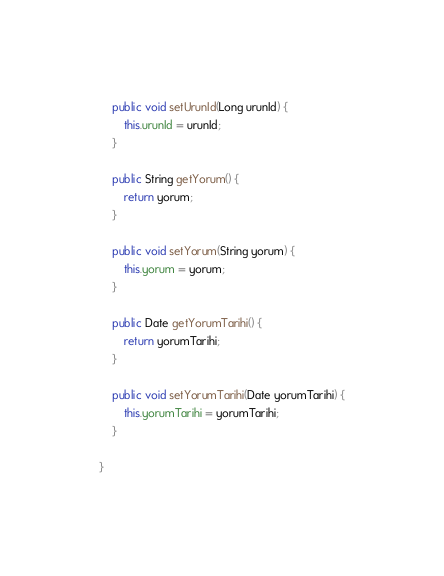Convert code to text. <code><loc_0><loc_0><loc_500><loc_500><_Java_>    public void setUrunId(Long urunId) {
        this.urunId = urunId;
    }

    public String getYorum() {
        return yorum;
    }

    public void setYorum(String yorum) {
        this.yorum = yorum;
    }

    public Date getYorumTarihi() {
        return yorumTarihi;
    }

    public void setYorumTarihi(Date yorumTarihi) {
        this.yorumTarihi = yorumTarihi;
    }

}
</code> 